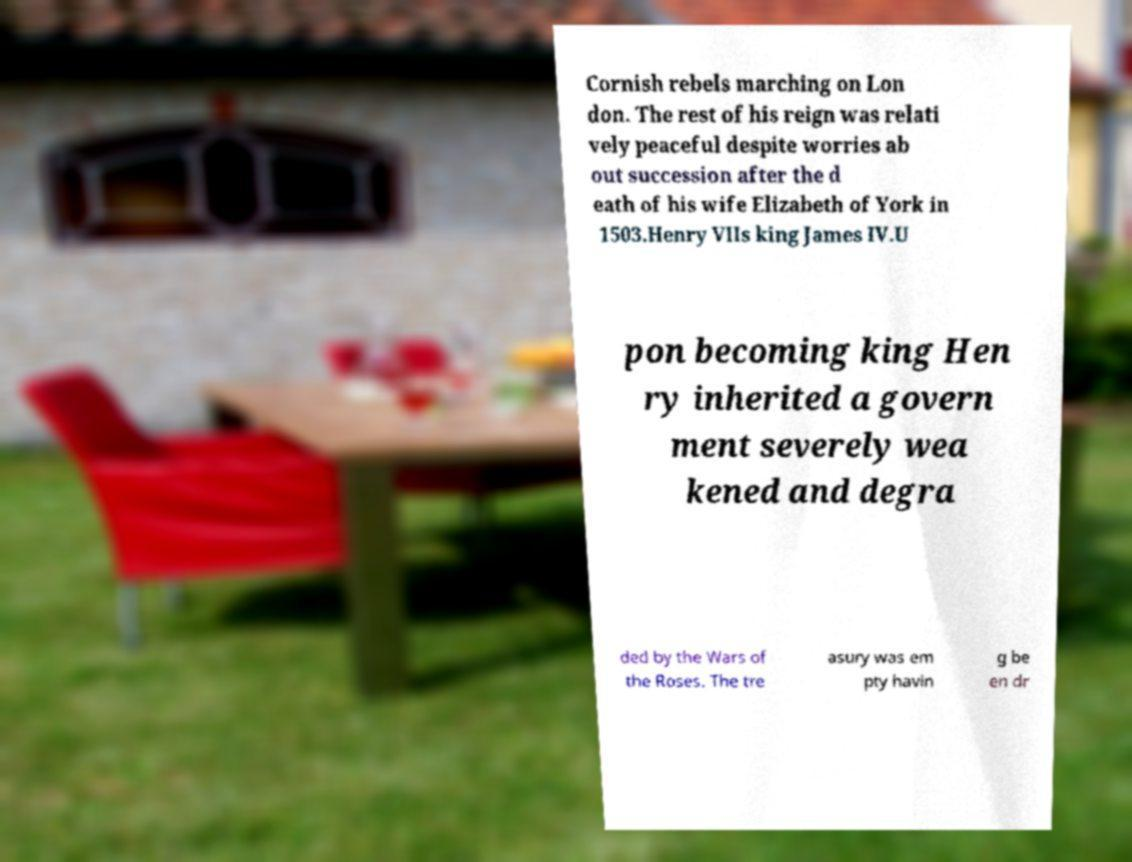I need the written content from this picture converted into text. Can you do that? Cornish rebels marching on Lon don. The rest of his reign was relati vely peaceful despite worries ab out succession after the d eath of his wife Elizabeth of York in 1503.Henry VIIs king James IV.U pon becoming king Hen ry inherited a govern ment severely wea kened and degra ded by the Wars of the Roses. The tre asury was em pty havin g be en dr 